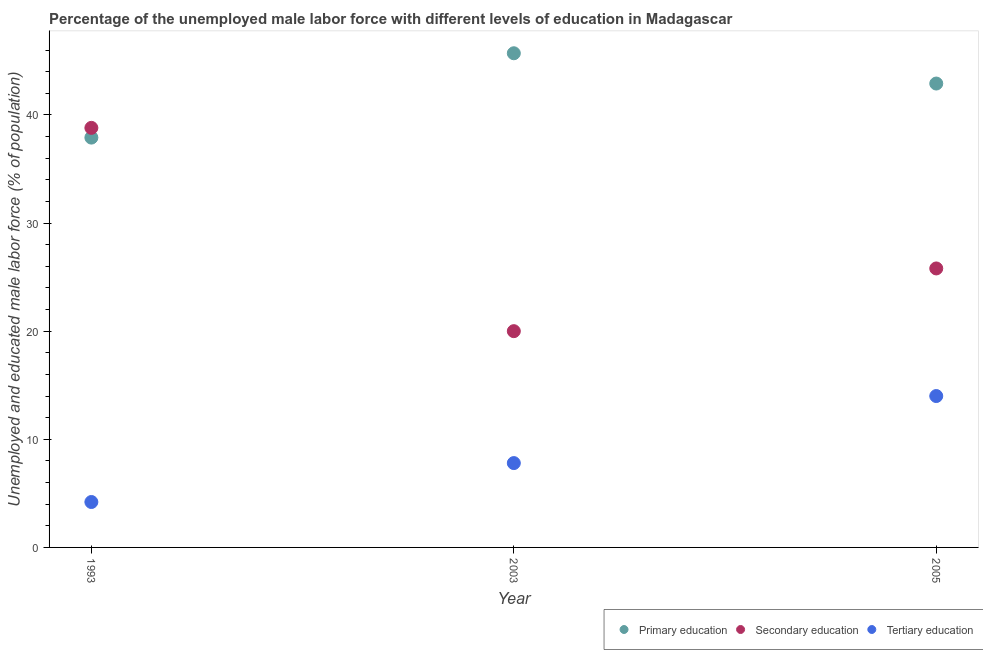How many different coloured dotlines are there?
Your answer should be very brief. 3. Is the number of dotlines equal to the number of legend labels?
Provide a succinct answer. Yes. What is the percentage of male labor force who received tertiary education in 1993?
Ensure brevity in your answer.  4.2. Across all years, what is the maximum percentage of male labor force who received primary education?
Your answer should be compact. 45.7. Across all years, what is the minimum percentage of male labor force who received tertiary education?
Provide a succinct answer. 4.2. In which year was the percentage of male labor force who received primary education maximum?
Make the answer very short. 2003. What is the total percentage of male labor force who received primary education in the graph?
Give a very brief answer. 126.5. What is the difference between the percentage of male labor force who received secondary education in 1993 and that in 2005?
Your answer should be compact. 13. What is the difference between the percentage of male labor force who received primary education in 1993 and the percentage of male labor force who received secondary education in 2005?
Your answer should be compact. 12.1. What is the average percentage of male labor force who received tertiary education per year?
Ensure brevity in your answer.  8.67. In the year 1993, what is the difference between the percentage of male labor force who received secondary education and percentage of male labor force who received primary education?
Keep it short and to the point. 0.9. What is the ratio of the percentage of male labor force who received primary education in 2003 to that in 2005?
Provide a short and direct response. 1.07. What is the difference between the highest and the second highest percentage of male labor force who received secondary education?
Your answer should be very brief. 13. What is the difference between the highest and the lowest percentage of male labor force who received tertiary education?
Keep it short and to the point. 9.8. Is the sum of the percentage of male labor force who received tertiary education in 2003 and 2005 greater than the maximum percentage of male labor force who received primary education across all years?
Give a very brief answer. No. Is the percentage of male labor force who received tertiary education strictly greater than the percentage of male labor force who received primary education over the years?
Your answer should be compact. No. How many years are there in the graph?
Offer a terse response. 3. Does the graph contain grids?
Your response must be concise. No. Where does the legend appear in the graph?
Provide a short and direct response. Bottom right. What is the title of the graph?
Make the answer very short. Percentage of the unemployed male labor force with different levels of education in Madagascar. Does "Tertiary" appear as one of the legend labels in the graph?
Give a very brief answer. No. What is the label or title of the X-axis?
Your response must be concise. Year. What is the label or title of the Y-axis?
Your answer should be very brief. Unemployed and educated male labor force (% of population). What is the Unemployed and educated male labor force (% of population) of Primary education in 1993?
Your answer should be very brief. 37.9. What is the Unemployed and educated male labor force (% of population) in Secondary education in 1993?
Ensure brevity in your answer.  38.8. What is the Unemployed and educated male labor force (% of population) of Tertiary education in 1993?
Provide a succinct answer. 4.2. What is the Unemployed and educated male labor force (% of population) of Primary education in 2003?
Keep it short and to the point. 45.7. What is the Unemployed and educated male labor force (% of population) in Tertiary education in 2003?
Your answer should be compact. 7.8. What is the Unemployed and educated male labor force (% of population) in Primary education in 2005?
Offer a very short reply. 42.9. What is the Unemployed and educated male labor force (% of population) in Secondary education in 2005?
Provide a succinct answer. 25.8. What is the Unemployed and educated male labor force (% of population) in Tertiary education in 2005?
Your answer should be compact. 14. Across all years, what is the maximum Unemployed and educated male labor force (% of population) of Primary education?
Provide a succinct answer. 45.7. Across all years, what is the maximum Unemployed and educated male labor force (% of population) of Secondary education?
Make the answer very short. 38.8. Across all years, what is the minimum Unemployed and educated male labor force (% of population) of Primary education?
Provide a short and direct response. 37.9. Across all years, what is the minimum Unemployed and educated male labor force (% of population) in Secondary education?
Your answer should be compact. 20. Across all years, what is the minimum Unemployed and educated male labor force (% of population) in Tertiary education?
Your answer should be compact. 4.2. What is the total Unemployed and educated male labor force (% of population) of Primary education in the graph?
Give a very brief answer. 126.5. What is the total Unemployed and educated male labor force (% of population) of Secondary education in the graph?
Provide a succinct answer. 84.6. What is the difference between the Unemployed and educated male labor force (% of population) of Primary education in 1993 and that in 2003?
Your response must be concise. -7.8. What is the difference between the Unemployed and educated male labor force (% of population) of Tertiary education in 1993 and that in 2003?
Provide a short and direct response. -3.6. What is the difference between the Unemployed and educated male labor force (% of population) in Primary education in 2003 and that in 2005?
Offer a terse response. 2.8. What is the difference between the Unemployed and educated male labor force (% of population) in Secondary education in 2003 and that in 2005?
Offer a very short reply. -5.8. What is the difference between the Unemployed and educated male labor force (% of population) of Tertiary education in 2003 and that in 2005?
Your answer should be compact. -6.2. What is the difference between the Unemployed and educated male labor force (% of population) of Primary education in 1993 and the Unemployed and educated male labor force (% of population) of Tertiary education in 2003?
Your answer should be compact. 30.1. What is the difference between the Unemployed and educated male labor force (% of population) of Secondary education in 1993 and the Unemployed and educated male labor force (% of population) of Tertiary education in 2003?
Your answer should be compact. 31. What is the difference between the Unemployed and educated male labor force (% of population) in Primary education in 1993 and the Unemployed and educated male labor force (% of population) in Tertiary education in 2005?
Provide a short and direct response. 23.9. What is the difference between the Unemployed and educated male labor force (% of population) of Secondary education in 1993 and the Unemployed and educated male labor force (% of population) of Tertiary education in 2005?
Ensure brevity in your answer.  24.8. What is the difference between the Unemployed and educated male labor force (% of population) in Primary education in 2003 and the Unemployed and educated male labor force (% of population) in Secondary education in 2005?
Keep it short and to the point. 19.9. What is the difference between the Unemployed and educated male labor force (% of population) of Primary education in 2003 and the Unemployed and educated male labor force (% of population) of Tertiary education in 2005?
Provide a short and direct response. 31.7. What is the difference between the Unemployed and educated male labor force (% of population) of Secondary education in 2003 and the Unemployed and educated male labor force (% of population) of Tertiary education in 2005?
Your answer should be compact. 6. What is the average Unemployed and educated male labor force (% of population) of Primary education per year?
Keep it short and to the point. 42.17. What is the average Unemployed and educated male labor force (% of population) of Secondary education per year?
Give a very brief answer. 28.2. What is the average Unemployed and educated male labor force (% of population) of Tertiary education per year?
Your answer should be very brief. 8.67. In the year 1993, what is the difference between the Unemployed and educated male labor force (% of population) in Primary education and Unemployed and educated male labor force (% of population) in Secondary education?
Make the answer very short. -0.9. In the year 1993, what is the difference between the Unemployed and educated male labor force (% of population) of Primary education and Unemployed and educated male labor force (% of population) of Tertiary education?
Your response must be concise. 33.7. In the year 1993, what is the difference between the Unemployed and educated male labor force (% of population) of Secondary education and Unemployed and educated male labor force (% of population) of Tertiary education?
Offer a terse response. 34.6. In the year 2003, what is the difference between the Unemployed and educated male labor force (% of population) in Primary education and Unemployed and educated male labor force (% of population) in Secondary education?
Offer a very short reply. 25.7. In the year 2003, what is the difference between the Unemployed and educated male labor force (% of population) in Primary education and Unemployed and educated male labor force (% of population) in Tertiary education?
Provide a succinct answer. 37.9. In the year 2003, what is the difference between the Unemployed and educated male labor force (% of population) in Secondary education and Unemployed and educated male labor force (% of population) in Tertiary education?
Make the answer very short. 12.2. In the year 2005, what is the difference between the Unemployed and educated male labor force (% of population) of Primary education and Unemployed and educated male labor force (% of population) of Secondary education?
Keep it short and to the point. 17.1. In the year 2005, what is the difference between the Unemployed and educated male labor force (% of population) in Primary education and Unemployed and educated male labor force (% of population) in Tertiary education?
Ensure brevity in your answer.  28.9. What is the ratio of the Unemployed and educated male labor force (% of population) of Primary education in 1993 to that in 2003?
Your response must be concise. 0.83. What is the ratio of the Unemployed and educated male labor force (% of population) of Secondary education in 1993 to that in 2003?
Your answer should be compact. 1.94. What is the ratio of the Unemployed and educated male labor force (% of population) in Tertiary education in 1993 to that in 2003?
Offer a terse response. 0.54. What is the ratio of the Unemployed and educated male labor force (% of population) of Primary education in 1993 to that in 2005?
Your answer should be compact. 0.88. What is the ratio of the Unemployed and educated male labor force (% of population) of Secondary education in 1993 to that in 2005?
Your answer should be compact. 1.5. What is the ratio of the Unemployed and educated male labor force (% of population) in Primary education in 2003 to that in 2005?
Offer a very short reply. 1.07. What is the ratio of the Unemployed and educated male labor force (% of population) of Secondary education in 2003 to that in 2005?
Ensure brevity in your answer.  0.78. What is the ratio of the Unemployed and educated male labor force (% of population) of Tertiary education in 2003 to that in 2005?
Ensure brevity in your answer.  0.56. What is the difference between the highest and the second highest Unemployed and educated male labor force (% of population) of Primary education?
Offer a terse response. 2.8. What is the difference between the highest and the second highest Unemployed and educated male labor force (% of population) in Tertiary education?
Offer a very short reply. 6.2. What is the difference between the highest and the lowest Unemployed and educated male labor force (% of population) of Tertiary education?
Provide a succinct answer. 9.8. 